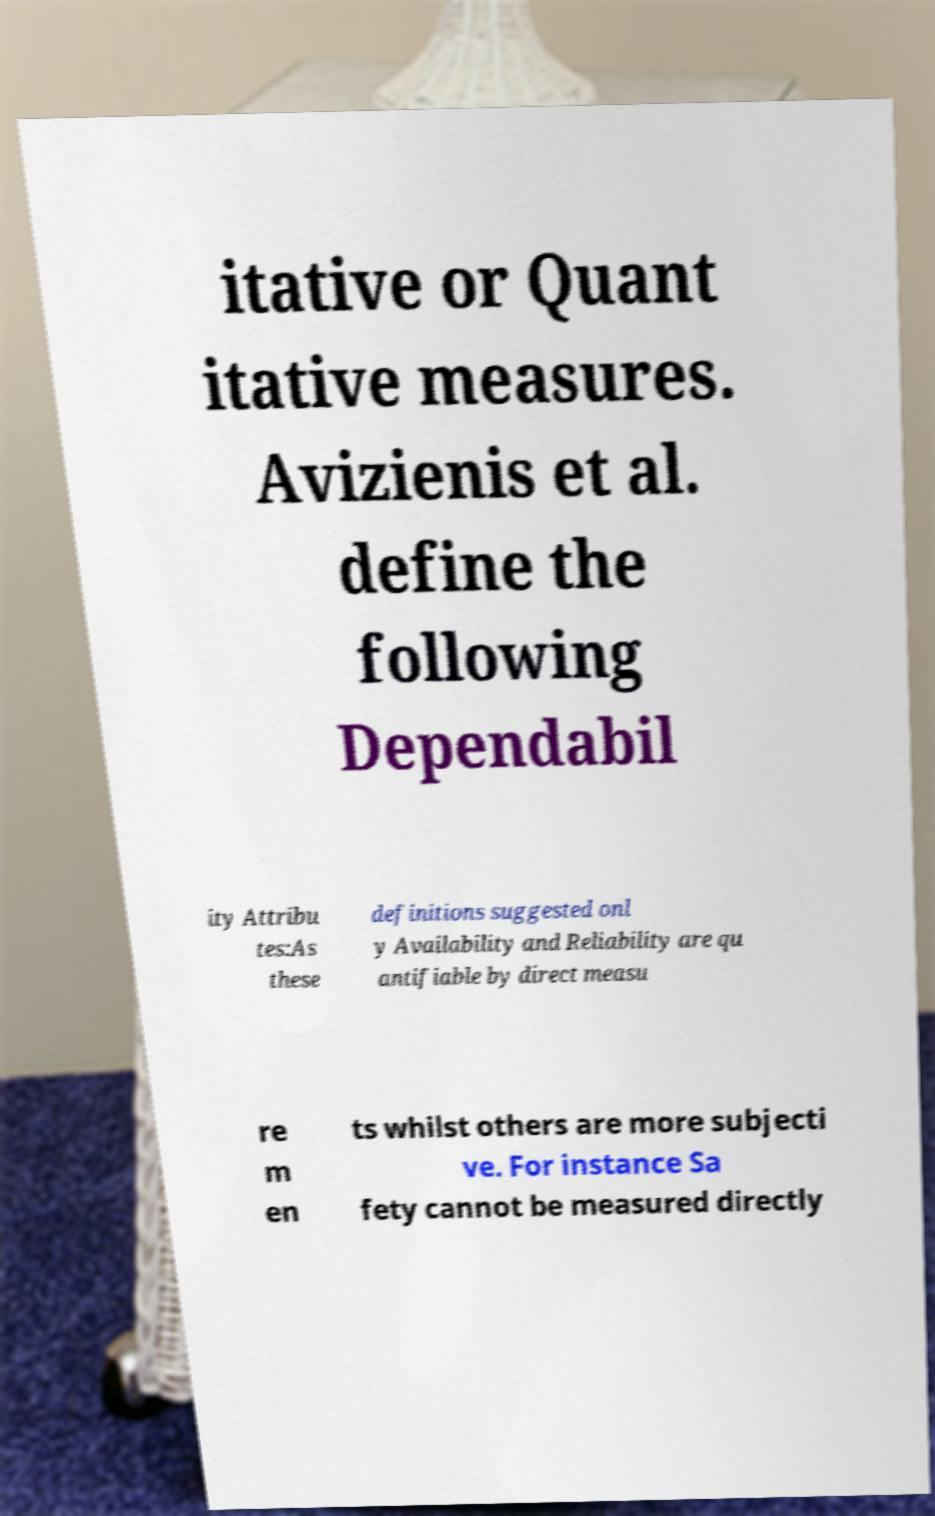Can you accurately transcribe the text from the provided image for me? itative or Quant itative measures. Avizienis et al. define the following Dependabil ity Attribu tes:As these definitions suggested onl y Availability and Reliability are qu antifiable by direct measu re m en ts whilst others are more subjecti ve. For instance Sa fety cannot be measured directly 